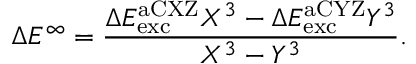<formula> <loc_0><loc_0><loc_500><loc_500>\Delta E ^ { \infty } = \frac { \Delta E _ { e x c } ^ { a C X Z } X ^ { 3 } - \Delta E _ { e x c } ^ { a C Y Z } Y ^ { 3 } } { X ^ { 3 } - Y ^ { 3 } } .</formula> 